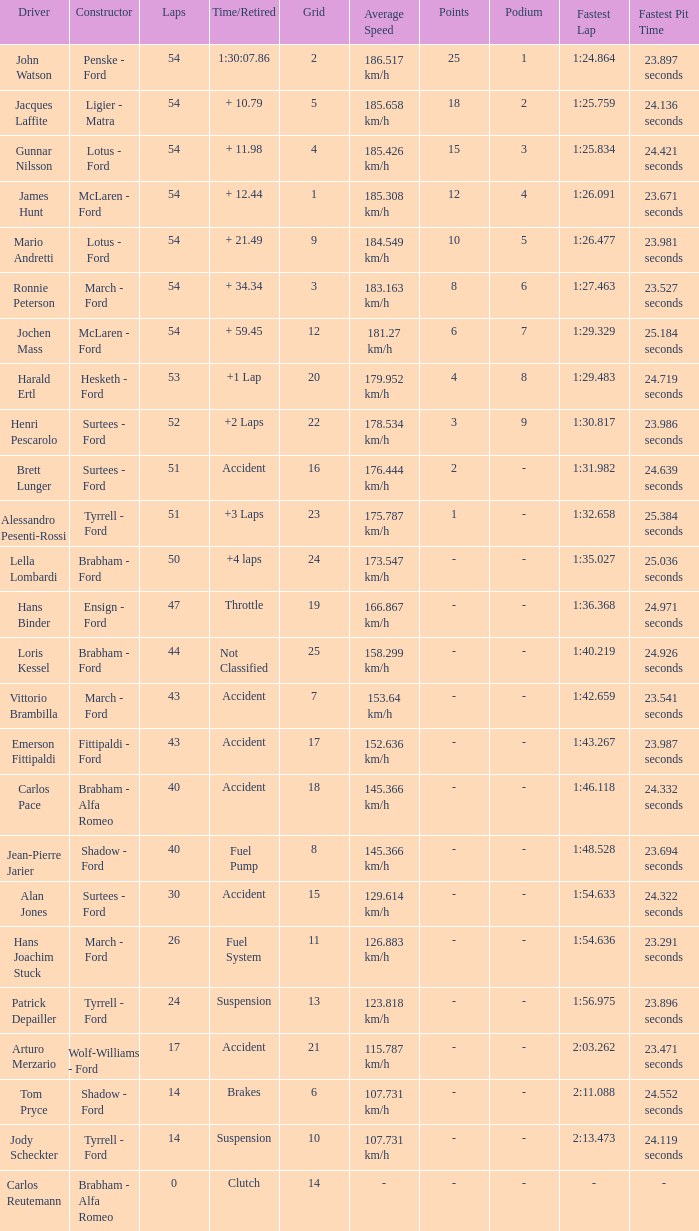What is the Time/Retired of Carlos Reutemann who was driving a brabham - Alfa Romeo? Clutch. Write the full table. {'header': ['Driver', 'Constructor', 'Laps', 'Time/Retired', 'Grid', 'Average Speed', 'Points', 'Podium', 'Fastest Lap', 'Fastest Pit Time '], 'rows': [['John Watson', 'Penske - Ford', '54', '1:30:07.86', '2', '186.517 km/h', '25', '1', '1:24.864', '23.897 seconds'], ['Jacques Laffite', 'Ligier - Matra', '54', '+ 10.79', '5', '185.658 km/h', '18', '2', '1:25.759', '24.136 seconds'], ['Gunnar Nilsson', 'Lotus - Ford', '54', '+ 11.98', '4', '185.426 km/h', '15', '3', '1:25.834', '24.421 seconds'], ['James Hunt', 'McLaren - Ford', '54', '+ 12.44', '1', '185.308 km/h', '12', '4', '1:26.091', '23.671 seconds'], ['Mario Andretti', 'Lotus - Ford', '54', '+ 21.49', '9', '184.549 km/h', '10', '5', '1:26.477', '23.981 seconds'], ['Ronnie Peterson', 'March - Ford', '54', '+ 34.34', '3', '183.163 km/h', '8', '6', '1:27.463', '23.527 seconds'], ['Jochen Mass', 'McLaren - Ford', '54', '+ 59.45', '12', '181.27 km/h', '6', '7', '1:29.329', '25.184 seconds'], ['Harald Ertl', 'Hesketh - Ford', '53', '+1 Lap', '20', '179.952 km/h', '4', '8', '1:29.483', '24.719 seconds'], ['Henri Pescarolo', 'Surtees - Ford', '52', '+2 Laps', '22', '178.534 km/h', '3', '9', '1:30.817', '23.986 seconds'], ['Brett Lunger', 'Surtees - Ford', '51', 'Accident', '16', '176.444 km/h', '2', '-', '1:31.982', '24.639 seconds'], ['Alessandro Pesenti-Rossi', 'Tyrrell - Ford', '51', '+3 Laps', '23', '175.787 km/h', '1', '-', '1:32.658', '25.384 seconds'], ['Lella Lombardi', 'Brabham - Ford', '50', '+4 laps', '24', '173.547 km/h', '-', '-', '1:35.027', '25.036 seconds'], ['Hans Binder', 'Ensign - Ford', '47', 'Throttle', '19', '166.867 km/h', '-', '-', '1:36.368', '24.971 seconds'], ['Loris Kessel', 'Brabham - Ford', '44', 'Not Classified', '25', '158.299 km/h', '-', '-', '1:40.219', '24.926 seconds'], ['Vittorio Brambilla', 'March - Ford', '43', 'Accident', '7', '153.64 km/h', '-', '-', '1:42.659', '23.541 seconds'], ['Emerson Fittipaldi', 'Fittipaldi - Ford', '43', 'Accident', '17', '152.636 km/h', '-', '-', '1:43.267', '23.987 seconds'], ['Carlos Pace', 'Brabham - Alfa Romeo', '40', 'Accident', '18', '145.366 km/h', '-', '-', '1:46.118', '24.332 seconds'], ['Jean-Pierre Jarier', 'Shadow - Ford', '40', 'Fuel Pump', '8', '145.366 km/h', '-', '-', '1:48.528', '23.694 seconds'], ['Alan Jones', 'Surtees - Ford', '30', 'Accident', '15', '129.614 km/h', '-', '-', '1:54.633', '24.322 seconds'], ['Hans Joachim Stuck', 'March - Ford', '26', 'Fuel System', '11', '126.883 km/h', '-', '-', '1:54.636', '23.291 seconds'], ['Patrick Depailler', 'Tyrrell - Ford', '24', 'Suspension', '13', '123.818 km/h', '-', '-', '1:56.975', '23.896 seconds'], ['Arturo Merzario', 'Wolf-Williams - Ford', '17', 'Accident', '21', '115.787 km/h', '-', '-', '2:03.262', '23.471 seconds'], ['Tom Pryce', 'Shadow - Ford', '14', 'Brakes', '6', '107.731 km/h', '-', '-', '2:11.088', '24.552 seconds'], ['Jody Scheckter', 'Tyrrell - Ford', '14', 'Suspension', '10', '107.731 km/h', '-', '-', '2:13.473', '24.119 seconds'], ['Carlos Reutemann', 'Brabham - Alfa Romeo', '0', 'Clutch', '14', '-', '-', '-', '-', '-']]} 